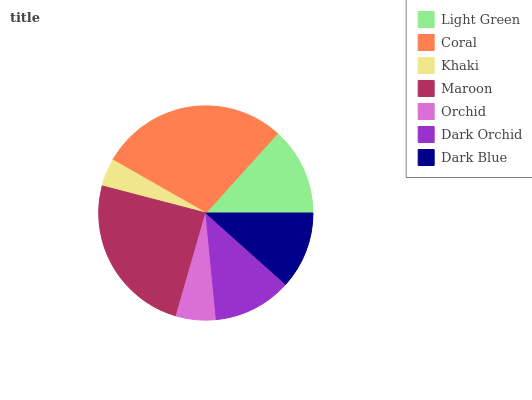Is Khaki the minimum?
Answer yes or no. Yes. Is Coral the maximum?
Answer yes or no. Yes. Is Coral the minimum?
Answer yes or no. No. Is Khaki the maximum?
Answer yes or no. No. Is Coral greater than Khaki?
Answer yes or no. Yes. Is Khaki less than Coral?
Answer yes or no. Yes. Is Khaki greater than Coral?
Answer yes or no. No. Is Coral less than Khaki?
Answer yes or no. No. Is Dark Orchid the high median?
Answer yes or no. Yes. Is Dark Orchid the low median?
Answer yes or no. Yes. Is Dark Blue the high median?
Answer yes or no. No. Is Dark Blue the low median?
Answer yes or no. No. 